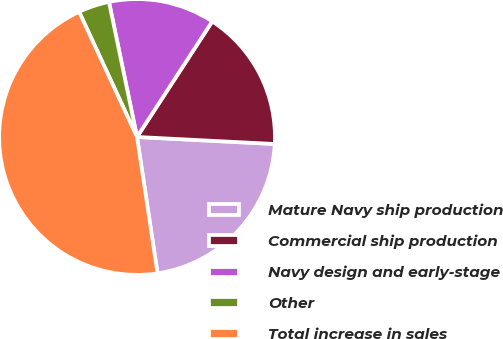Convert chart. <chart><loc_0><loc_0><loc_500><loc_500><pie_chart><fcel>Mature Navy ship production<fcel>Commercial ship production<fcel>Navy design and early-stage<fcel>Other<fcel>Total increase in sales<nl><fcel>21.81%<fcel>16.63%<fcel>12.44%<fcel>3.64%<fcel>45.48%<nl></chart> 